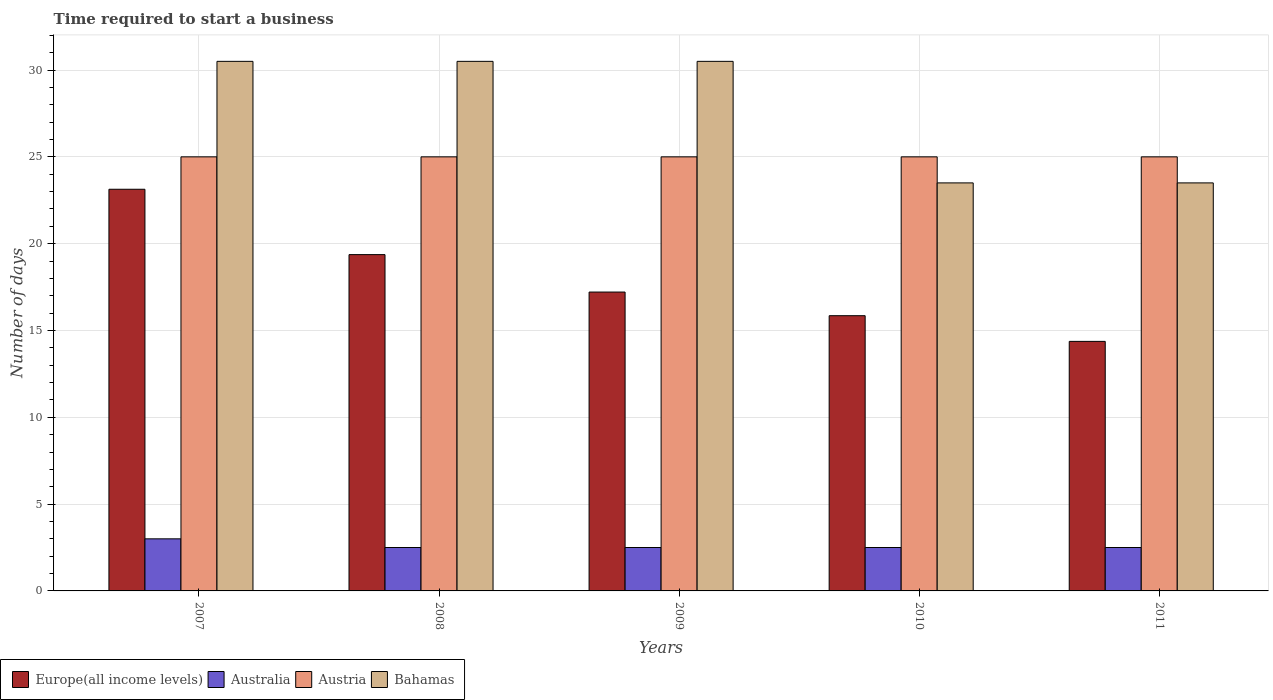How many bars are there on the 5th tick from the left?
Offer a terse response. 4. How many bars are there on the 3rd tick from the right?
Your answer should be very brief. 4. What is the label of the 5th group of bars from the left?
Offer a terse response. 2011. In how many cases, is the number of bars for a given year not equal to the number of legend labels?
Your answer should be very brief. 0. What is the number of days required to start a business in Bahamas in 2007?
Give a very brief answer. 30.5. Across all years, what is the maximum number of days required to start a business in Europe(all income levels)?
Your response must be concise. 23.13. What is the total number of days required to start a business in Austria in the graph?
Provide a short and direct response. 125. What is the difference between the number of days required to start a business in Europe(all income levels) in 2009 and that in 2010?
Your response must be concise. 1.36. What is the difference between the number of days required to start a business in Austria in 2011 and the number of days required to start a business in Europe(all income levels) in 2010?
Your answer should be very brief. 9.15. What is the average number of days required to start a business in Bahamas per year?
Offer a very short reply. 27.7. In how many years, is the number of days required to start a business in Europe(all income levels) greater than 16 days?
Ensure brevity in your answer.  3. What is the ratio of the number of days required to start a business in Europe(all income levels) in 2007 to that in 2009?
Provide a succinct answer. 1.34. What is the difference between the highest and the lowest number of days required to start a business in Australia?
Your answer should be compact. 0.5. In how many years, is the number of days required to start a business in Europe(all income levels) greater than the average number of days required to start a business in Europe(all income levels) taken over all years?
Your answer should be very brief. 2. Is the sum of the number of days required to start a business in Austria in 2008 and 2009 greater than the maximum number of days required to start a business in Australia across all years?
Offer a very short reply. Yes. Is it the case that in every year, the sum of the number of days required to start a business in Bahamas and number of days required to start a business in Australia is greater than the sum of number of days required to start a business in Europe(all income levels) and number of days required to start a business in Austria?
Offer a very short reply. No. What does the 1st bar from the right in 2011 represents?
Offer a very short reply. Bahamas. Is it the case that in every year, the sum of the number of days required to start a business in Austria and number of days required to start a business in Europe(all income levels) is greater than the number of days required to start a business in Bahamas?
Ensure brevity in your answer.  Yes. How many bars are there?
Offer a terse response. 20. How many years are there in the graph?
Offer a terse response. 5. Are the values on the major ticks of Y-axis written in scientific E-notation?
Offer a terse response. No. Does the graph contain grids?
Your response must be concise. Yes. What is the title of the graph?
Offer a very short reply. Time required to start a business. What is the label or title of the Y-axis?
Ensure brevity in your answer.  Number of days. What is the Number of days in Europe(all income levels) in 2007?
Make the answer very short. 23.13. What is the Number of days of Australia in 2007?
Make the answer very short. 3. What is the Number of days in Austria in 2007?
Your answer should be compact. 25. What is the Number of days of Bahamas in 2007?
Offer a very short reply. 30.5. What is the Number of days of Europe(all income levels) in 2008?
Your answer should be compact. 19.37. What is the Number of days in Austria in 2008?
Provide a succinct answer. 25. What is the Number of days in Bahamas in 2008?
Make the answer very short. 30.5. What is the Number of days of Europe(all income levels) in 2009?
Provide a succinct answer. 17.21. What is the Number of days in Austria in 2009?
Make the answer very short. 25. What is the Number of days in Bahamas in 2009?
Your answer should be compact. 30.5. What is the Number of days of Europe(all income levels) in 2010?
Your answer should be very brief. 15.85. What is the Number of days of Austria in 2010?
Ensure brevity in your answer.  25. What is the Number of days in Europe(all income levels) in 2011?
Give a very brief answer. 14.37. What is the Number of days in Australia in 2011?
Provide a succinct answer. 2.5. What is the Number of days in Bahamas in 2011?
Offer a very short reply. 23.5. Across all years, what is the maximum Number of days of Europe(all income levels)?
Provide a short and direct response. 23.13. Across all years, what is the maximum Number of days of Australia?
Keep it short and to the point. 3. Across all years, what is the maximum Number of days in Bahamas?
Provide a short and direct response. 30.5. Across all years, what is the minimum Number of days in Europe(all income levels)?
Ensure brevity in your answer.  14.37. Across all years, what is the minimum Number of days in Austria?
Offer a very short reply. 25. What is the total Number of days of Europe(all income levels) in the graph?
Provide a succinct answer. 89.94. What is the total Number of days in Australia in the graph?
Provide a succinct answer. 13. What is the total Number of days in Austria in the graph?
Provide a short and direct response. 125. What is the total Number of days of Bahamas in the graph?
Ensure brevity in your answer.  138.5. What is the difference between the Number of days of Europe(all income levels) in 2007 and that in 2008?
Offer a terse response. 3.76. What is the difference between the Number of days of Europe(all income levels) in 2007 and that in 2009?
Ensure brevity in your answer.  5.92. What is the difference between the Number of days of Europe(all income levels) in 2007 and that in 2010?
Provide a short and direct response. 7.28. What is the difference between the Number of days of Australia in 2007 and that in 2010?
Your response must be concise. 0.5. What is the difference between the Number of days of Bahamas in 2007 and that in 2010?
Keep it short and to the point. 7. What is the difference between the Number of days of Europe(all income levels) in 2007 and that in 2011?
Offer a terse response. 8.76. What is the difference between the Number of days of Bahamas in 2007 and that in 2011?
Provide a succinct answer. 7. What is the difference between the Number of days of Europe(all income levels) in 2008 and that in 2009?
Provide a short and direct response. 2.16. What is the difference between the Number of days in Australia in 2008 and that in 2009?
Offer a terse response. 0. What is the difference between the Number of days in Austria in 2008 and that in 2009?
Provide a short and direct response. 0. What is the difference between the Number of days in Europe(all income levels) in 2008 and that in 2010?
Your response must be concise. 3.52. What is the difference between the Number of days in Australia in 2008 and that in 2010?
Your response must be concise. 0. What is the difference between the Number of days in Austria in 2008 and that in 2010?
Your answer should be compact. 0. What is the difference between the Number of days of Bahamas in 2008 and that in 2010?
Ensure brevity in your answer.  7. What is the difference between the Number of days in Europe(all income levels) in 2008 and that in 2011?
Ensure brevity in your answer.  5. What is the difference between the Number of days in Austria in 2008 and that in 2011?
Make the answer very short. 0. What is the difference between the Number of days of Bahamas in 2008 and that in 2011?
Provide a succinct answer. 7. What is the difference between the Number of days in Europe(all income levels) in 2009 and that in 2010?
Offer a terse response. 1.36. What is the difference between the Number of days of Australia in 2009 and that in 2010?
Offer a very short reply. 0. What is the difference between the Number of days of Europe(all income levels) in 2009 and that in 2011?
Provide a short and direct response. 2.84. What is the difference between the Number of days in Bahamas in 2009 and that in 2011?
Your answer should be compact. 7. What is the difference between the Number of days of Europe(all income levels) in 2010 and that in 2011?
Offer a very short reply. 1.48. What is the difference between the Number of days in Australia in 2010 and that in 2011?
Provide a succinct answer. 0. What is the difference between the Number of days in Bahamas in 2010 and that in 2011?
Your answer should be compact. 0. What is the difference between the Number of days in Europe(all income levels) in 2007 and the Number of days in Australia in 2008?
Provide a succinct answer. 20.63. What is the difference between the Number of days in Europe(all income levels) in 2007 and the Number of days in Austria in 2008?
Offer a very short reply. -1.87. What is the difference between the Number of days of Europe(all income levels) in 2007 and the Number of days of Bahamas in 2008?
Provide a short and direct response. -7.37. What is the difference between the Number of days in Australia in 2007 and the Number of days in Austria in 2008?
Offer a very short reply. -22. What is the difference between the Number of days in Australia in 2007 and the Number of days in Bahamas in 2008?
Ensure brevity in your answer.  -27.5. What is the difference between the Number of days in Europe(all income levels) in 2007 and the Number of days in Australia in 2009?
Your answer should be very brief. 20.63. What is the difference between the Number of days of Europe(all income levels) in 2007 and the Number of days of Austria in 2009?
Provide a short and direct response. -1.87. What is the difference between the Number of days in Europe(all income levels) in 2007 and the Number of days in Bahamas in 2009?
Your answer should be compact. -7.37. What is the difference between the Number of days of Australia in 2007 and the Number of days of Austria in 2009?
Your answer should be very brief. -22. What is the difference between the Number of days in Australia in 2007 and the Number of days in Bahamas in 2009?
Give a very brief answer. -27.5. What is the difference between the Number of days of Europe(all income levels) in 2007 and the Number of days of Australia in 2010?
Make the answer very short. 20.63. What is the difference between the Number of days in Europe(all income levels) in 2007 and the Number of days in Austria in 2010?
Ensure brevity in your answer.  -1.87. What is the difference between the Number of days in Europe(all income levels) in 2007 and the Number of days in Bahamas in 2010?
Keep it short and to the point. -0.37. What is the difference between the Number of days in Australia in 2007 and the Number of days in Austria in 2010?
Ensure brevity in your answer.  -22. What is the difference between the Number of days in Australia in 2007 and the Number of days in Bahamas in 2010?
Offer a very short reply. -20.5. What is the difference between the Number of days in Austria in 2007 and the Number of days in Bahamas in 2010?
Make the answer very short. 1.5. What is the difference between the Number of days in Europe(all income levels) in 2007 and the Number of days in Australia in 2011?
Give a very brief answer. 20.63. What is the difference between the Number of days of Europe(all income levels) in 2007 and the Number of days of Austria in 2011?
Provide a succinct answer. -1.87. What is the difference between the Number of days of Europe(all income levels) in 2007 and the Number of days of Bahamas in 2011?
Provide a succinct answer. -0.37. What is the difference between the Number of days in Australia in 2007 and the Number of days in Austria in 2011?
Offer a very short reply. -22. What is the difference between the Number of days of Australia in 2007 and the Number of days of Bahamas in 2011?
Your response must be concise. -20.5. What is the difference between the Number of days in Austria in 2007 and the Number of days in Bahamas in 2011?
Your response must be concise. 1.5. What is the difference between the Number of days of Europe(all income levels) in 2008 and the Number of days of Australia in 2009?
Offer a very short reply. 16.87. What is the difference between the Number of days of Europe(all income levels) in 2008 and the Number of days of Austria in 2009?
Offer a very short reply. -5.63. What is the difference between the Number of days of Europe(all income levels) in 2008 and the Number of days of Bahamas in 2009?
Your response must be concise. -11.13. What is the difference between the Number of days of Australia in 2008 and the Number of days of Austria in 2009?
Offer a terse response. -22.5. What is the difference between the Number of days in Austria in 2008 and the Number of days in Bahamas in 2009?
Offer a very short reply. -5.5. What is the difference between the Number of days in Europe(all income levels) in 2008 and the Number of days in Australia in 2010?
Provide a short and direct response. 16.87. What is the difference between the Number of days of Europe(all income levels) in 2008 and the Number of days of Austria in 2010?
Provide a succinct answer. -5.63. What is the difference between the Number of days in Europe(all income levels) in 2008 and the Number of days in Bahamas in 2010?
Offer a very short reply. -4.13. What is the difference between the Number of days in Australia in 2008 and the Number of days in Austria in 2010?
Keep it short and to the point. -22.5. What is the difference between the Number of days in Australia in 2008 and the Number of days in Bahamas in 2010?
Your answer should be very brief. -21. What is the difference between the Number of days of Austria in 2008 and the Number of days of Bahamas in 2010?
Your answer should be compact. 1.5. What is the difference between the Number of days of Europe(all income levels) in 2008 and the Number of days of Australia in 2011?
Provide a succinct answer. 16.87. What is the difference between the Number of days of Europe(all income levels) in 2008 and the Number of days of Austria in 2011?
Your answer should be compact. -5.63. What is the difference between the Number of days of Europe(all income levels) in 2008 and the Number of days of Bahamas in 2011?
Provide a succinct answer. -4.13. What is the difference between the Number of days of Australia in 2008 and the Number of days of Austria in 2011?
Your response must be concise. -22.5. What is the difference between the Number of days of Europe(all income levels) in 2009 and the Number of days of Australia in 2010?
Keep it short and to the point. 14.71. What is the difference between the Number of days in Europe(all income levels) in 2009 and the Number of days in Austria in 2010?
Provide a short and direct response. -7.79. What is the difference between the Number of days in Europe(all income levels) in 2009 and the Number of days in Bahamas in 2010?
Give a very brief answer. -6.29. What is the difference between the Number of days in Australia in 2009 and the Number of days in Austria in 2010?
Your response must be concise. -22.5. What is the difference between the Number of days in Europe(all income levels) in 2009 and the Number of days in Australia in 2011?
Offer a terse response. 14.71. What is the difference between the Number of days of Europe(all income levels) in 2009 and the Number of days of Austria in 2011?
Your answer should be very brief. -7.79. What is the difference between the Number of days of Europe(all income levels) in 2009 and the Number of days of Bahamas in 2011?
Give a very brief answer. -6.29. What is the difference between the Number of days in Australia in 2009 and the Number of days in Austria in 2011?
Keep it short and to the point. -22.5. What is the difference between the Number of days in Austria in 2009 and the Number of days in Bahamas in 2011?
Provide a succinct answer. 1.5. What is the difference between the Number of days in Europe(all income levels) in 2010 and the Number of days in Australia in 2011?
Keep it short and to the point. 13.35. What is the difference between the Number of days in Europe(all income levels) in 2010 and the Number of days in Austria in 2011?
Your response must be concise. -9.15. What is the difference between the Number of days of Europe(all income levels) in 2010 and the Number of days of Bahamas in 2011?
Provide a short and direct response. -7.65. What is the difference between the Number of days of Australia in 2010 and the Number of days of Austria in 2011?
Your answer should be very brief. -22.5. What is the difference between the Number of days of Australia in 2010 and the Number of days of Bahamas in 2011?
Make the answer very short. -21. What is the average Number of days of Europe(all income levels) per year?
Give a very brief answer. 17.99. What is the average Number of days in Australia per year?
Make the answer very short. 2.6. What is the average Number of days in Austria per year?
Your answer should be compact. 25. What is the average Number of days in Bahamas per year?
Make the answer very short. 27.7. In the year 2007, what is the difference between the Number of days of Europe(all income levels) and Number of days of Australia?
Keep it short and to the point. 20.13. In the year 2007, what is the difference between the Number of days of Europe(all income levels) and Number of days of Austria?
Your response must be concise. -1.87. In the year 2007, what is the difference between the Number of days of Europe(all income levels) and Number of days of Bahamas?
Provide a short and direct response. -7.37. In the year 2007, what is the difference between the Number of days of Australia and Number of days of Bahamas?
Your answer should be compact. -27.5. In the year 2008, what is the difference between the Number of days of Europe(all income levels) and Number of days of Australia?
Your answer should be very brief. 16.87. In the year 2008, what is the difference between the Number of days of Europe(all income levels) and Number of days of Austria?
Provide a succinct answer. -5.63. In the year 2008, what is the difference between the Number of days in Europe(all income levels) and Number of days in Bahamas?
Ensure brevity in your answer.  -11.13. In the year 2008, what is the difference between the Number of days in Australia and Number of days in Austria?
Keep it short and to the point. -22.5. In the year 2008, what is the difference between the Number of days in Australia and Number of days in Bahamas?
Keep it short and to the point. -28. In the year 2009, what is the difference between the Number of days of Europe(all income levels) and Number of days of Australia?
Provide a short and direct response. 14.71. In the year 2009, what is the difference between the Number of days in Europe(all income levels) and Number of days in Austria?
Offer a terse response. -7.79. In the year 2009, what is the difference between the Number of days in Europe(all income levels) and Number of days in Bahamas?
Make the answer very short. -13.29. In the year 2009, what is the difference between the Number of days in Australia and Number of days in Austria?
Keep it short and to the point. -22.5. In the year 2009, what is the difference between the Number of days in Australia and Number of days in Bahamas?
Keep it short and to the point. -28. In the year 2010, what is the difference between the Number of days in Europe(all income levels) and Number of days in Australia?
Offer a terse response. 13.35. In the year 2010, what is the difference between the Number of days in Europe(all income levels) and Number of days in Austria?
Offer a very short reply. -9.15. In the year 2010, what is the difference between the Number of days in Europe(all income levels) and Number of days in Bahamas?
Give a very brief answer. -7.65. In the year 2010, what is the difference between the Number of days of Australia and Number of days of Austria?
Your response must be concise. -22.5. In the year 2010, what is the difference between the Number of days in Austria and Number of days in Bahamas?
Your answer should be very brief. 1.5. In the year 2011, what is the difference between the Number of days in Europe(all income levels) and Number of days in Australia?
Make the answer very short. 11.87. In the year 2011, what is the difference between the Number of days of Europe(all income levels) and Number of days of Austria?
Give a very brief answer. -10.63. In the year 2011, what is the difference between the Number of days in Europe(all income levels) and Number of days in Bahamas?
Give a very brief answer. -9.13. In the year 2011, what is the difference between the Number of days of Australia and Number of days of Austria?
Offer a terse response. -22.5. In the year 2011, what is the difference between the Number of days of Austria and Number of days of Bahamas?
Your response must be concise. 1.5. What is the ratio of the Number of days in Europe(all income levels) in 2007 to that in 2008?
Provide a succinct answer. 1.19. What is the ratio of the Number of days in Bahamas in 2007 to that in 2008?
Your answer should be very brief. 1. What is the ratio of the Number of days of Europe(all income levels) in 2007 to that in 2009?
Keep it short and to the point. 1.34. What is the ratio of the Number of days of Austria in 2007 to that in 2009?
Ensure brevity in your answer.  1. What is the ratio of the Number of days of Europe(all income levels) in 2007 to that in 2010?
Your response must be concise. 1.46. What is the ratio of the Number of days of Australia in 2007 to that in 2010?
Keep it short and to the point. 1.2. What is the ratio of the Number of days of Bahamas in 2007 to that in 2010?
Provide a short and direct response. 1.3. What is the ratio of the Number of days in Europe(all income levels) in 2007 to that in 2011?
Offer a very short reply. 1.61. What is the ratio of the Number of days in Austria in 2007 to that in 2011?
Your answer should be very brief. 1. What is the ratio of the Number of days in Bahamas in 2007 to that in 2011?
Provide a succinct answer. 1.3. What is the ratio of the Number of days in Europe(all income levels) in 2008 to that in 2009?
Provide a short and direct response. 1.13. What is the ratio of the Number of days in Australia in 2008 to that in 2009?
Ensure brevity in your answer.  1. What is the ratio of the Number of days of Austria in 2008 to that in 2009?
Keep it short and to the point. 1. What is the ratio of the Number of days of Europe(all income levels) in 2008 to that in 2010?
Offer a very short reply. 1.22. What is the ratio of the Number of days of Australia in 2008 to that in 2010?
Give a very brief answer. 1. What is the ratio of the Number of days of Austria in 2008 to that in 2010?
Keep it short and to the point. 1. What is the ratio of the Number of days of Bahamas in 2008 to that in 2010?
Your answer should be very brief. 1.3. What is the ratio of the Number of days of Europe(all income levels) in 2008 to that in 2011?
Your response must be concise. 1.35. What is the ratio of the Number of days of Australia in 2008 to that in 2011?
Keep it short and to the point. 1. What is the ratio of the Number of days in Austria in 2008 to that in 2011?
Provide a succinct answer. 1. What is the ratio of the Number of days of Bahamas in 2008 to that in 2011?
Provide a succinct answer. 1.3. What is the ratio of the Number of days of Europe(all income levels) in 2009 to that in 2010?
Make the answer very short. 1.09. What is the ratio of the Number of days in Bahamas in 2009 to that in 2010?
Offer a very short reply. 1.3. What is the ratio of the Number of days in Europe(all income levels) in 2009 to that in 2011?
Make the answer very short. 1.2. What is the ratio of the Number of days of Australia in 2009 to that in 2011?
Ensure brevity in your answer.  1. What is the ratio of the Number of days of Austria in 2009 to that in 2011?
Offer a terse response. 1. What is the ratio of the Number of days of Bahamas in 2009 to that in 2011?
Provide a succinct answer. 1.3. What is the ratio of the Number of days of Europe(all income levels) in 2010 to that in 2011?
Your response must be concise. 1.1. What is the ratio of the Number of days of Austria in 2010 to that in 2011?
Offer a very short reply. 1. What is the ratio of the Number of days of Bahamas in 2010 to that in 2011?
Your answer should be compact. 1. What is the difference between the highest and the second highest Number of days in Europe(all income levels)?
Make the answer very short. 3.76. What is the difference between the highest and the second highest Number of days in Australia?
Offer a terse response. 0.5. What is the difference between the highest and the second highest Number of days of Bahamas?
Your response must be concise. 0. What is the difference between the highest and the lowest Number of days of Europe(all income levels)?
Your answer should be compact. 8.76. What is the difference between the highest and the lowest Number of days of Australia?
Give a very brief answer. 0.5. What is the difference between the highest and the lowest Number of days in Austria?
Your answer should be compact. 0. What is the difference between the highest and the lowest Number of days of Bahamas?
Your response must be concise. 7. 